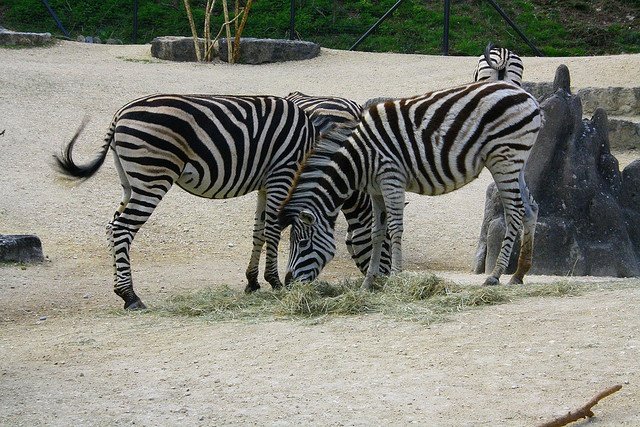Describe the objects in this image and their specific colors. I can see zebra in darkgreen, black, gray, and darkgray tones, zebra in darkgreen, black, gray, and darkgray tones, and zebra in darkgreen, darkgray, black, gray, and lightgray tones in this image. 